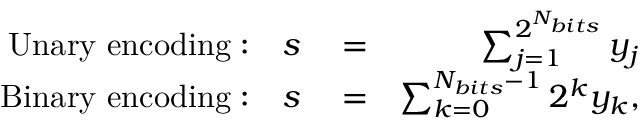Convert formula to latex. <formula><loc_0><loc_0><loc_500><loc_500>\begin{array} { r l r } { U n a r y \ e n c o d i n g \colon \quad s } & = } & { \sum _ { j = 1 } ^ { 2 ^ { N _ { b i t s } } } y _ { j } } \\ { B i n a r y \ e n c o d i n g \colon \quad s } & = } & { \sum _ { k = 0 } ^ { N _ { b i t s } - 1 } 2 ^ { k } y _ { k } , } \end{array}</formula> 